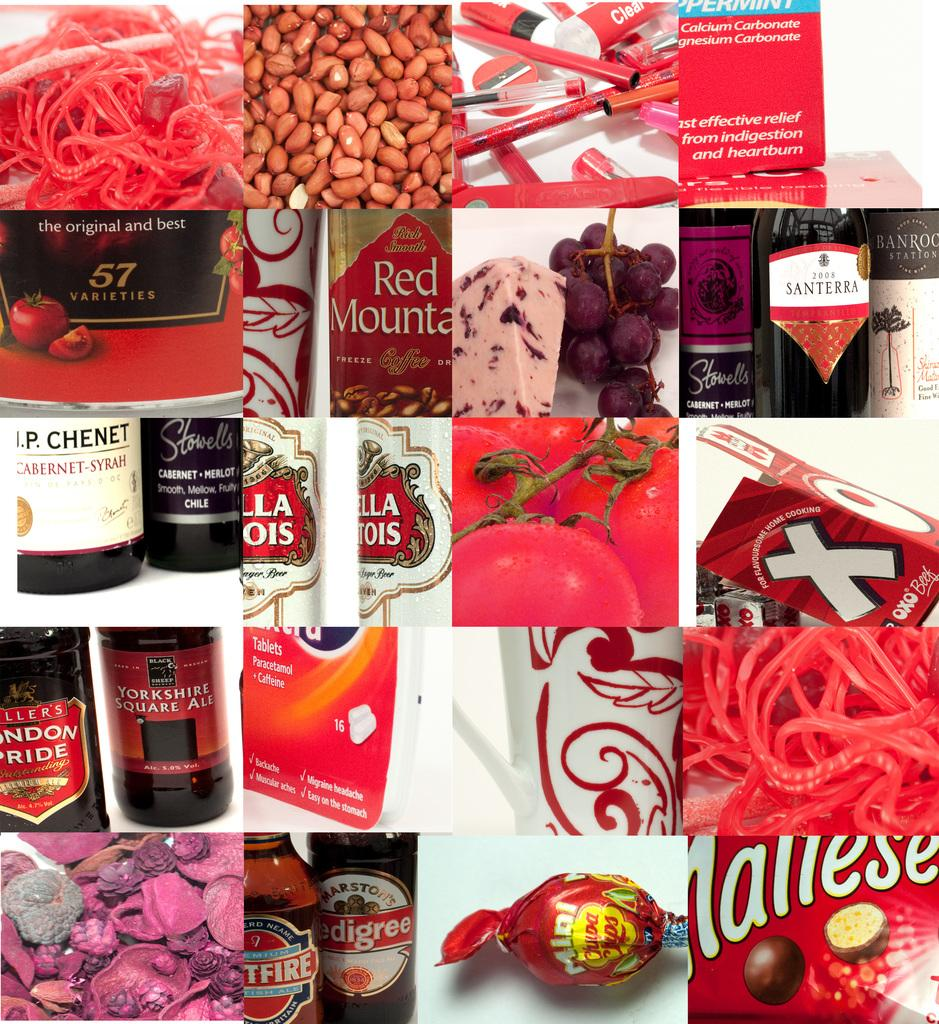Provide a one-sentence caption for the provided image. A collection of joined pictures depicts numerous products, like Red Mountain and Stella Artois. 